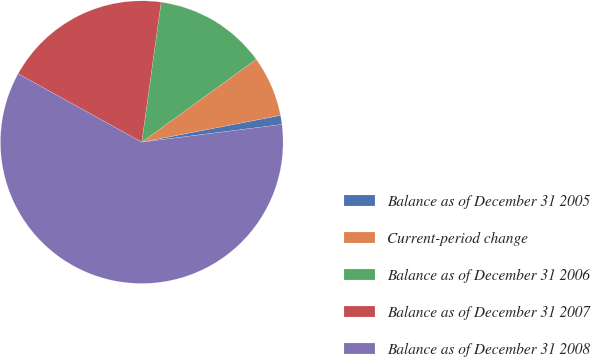<chart> <loc_0><loc_0><loc_500><loc_500><pie_chart><fcel>Balance as of December 31 2005<fcel>Current-period change<fcel>Balance as of December 31 2006<fcel>Balance as of December 31 2007<fcel>Balance as of December 31 2008<nl><fcel>1.04%<fcel>6.94%<fcel>12.84%<fcel>19.15%<fcel>60.04%<nl></chart> 